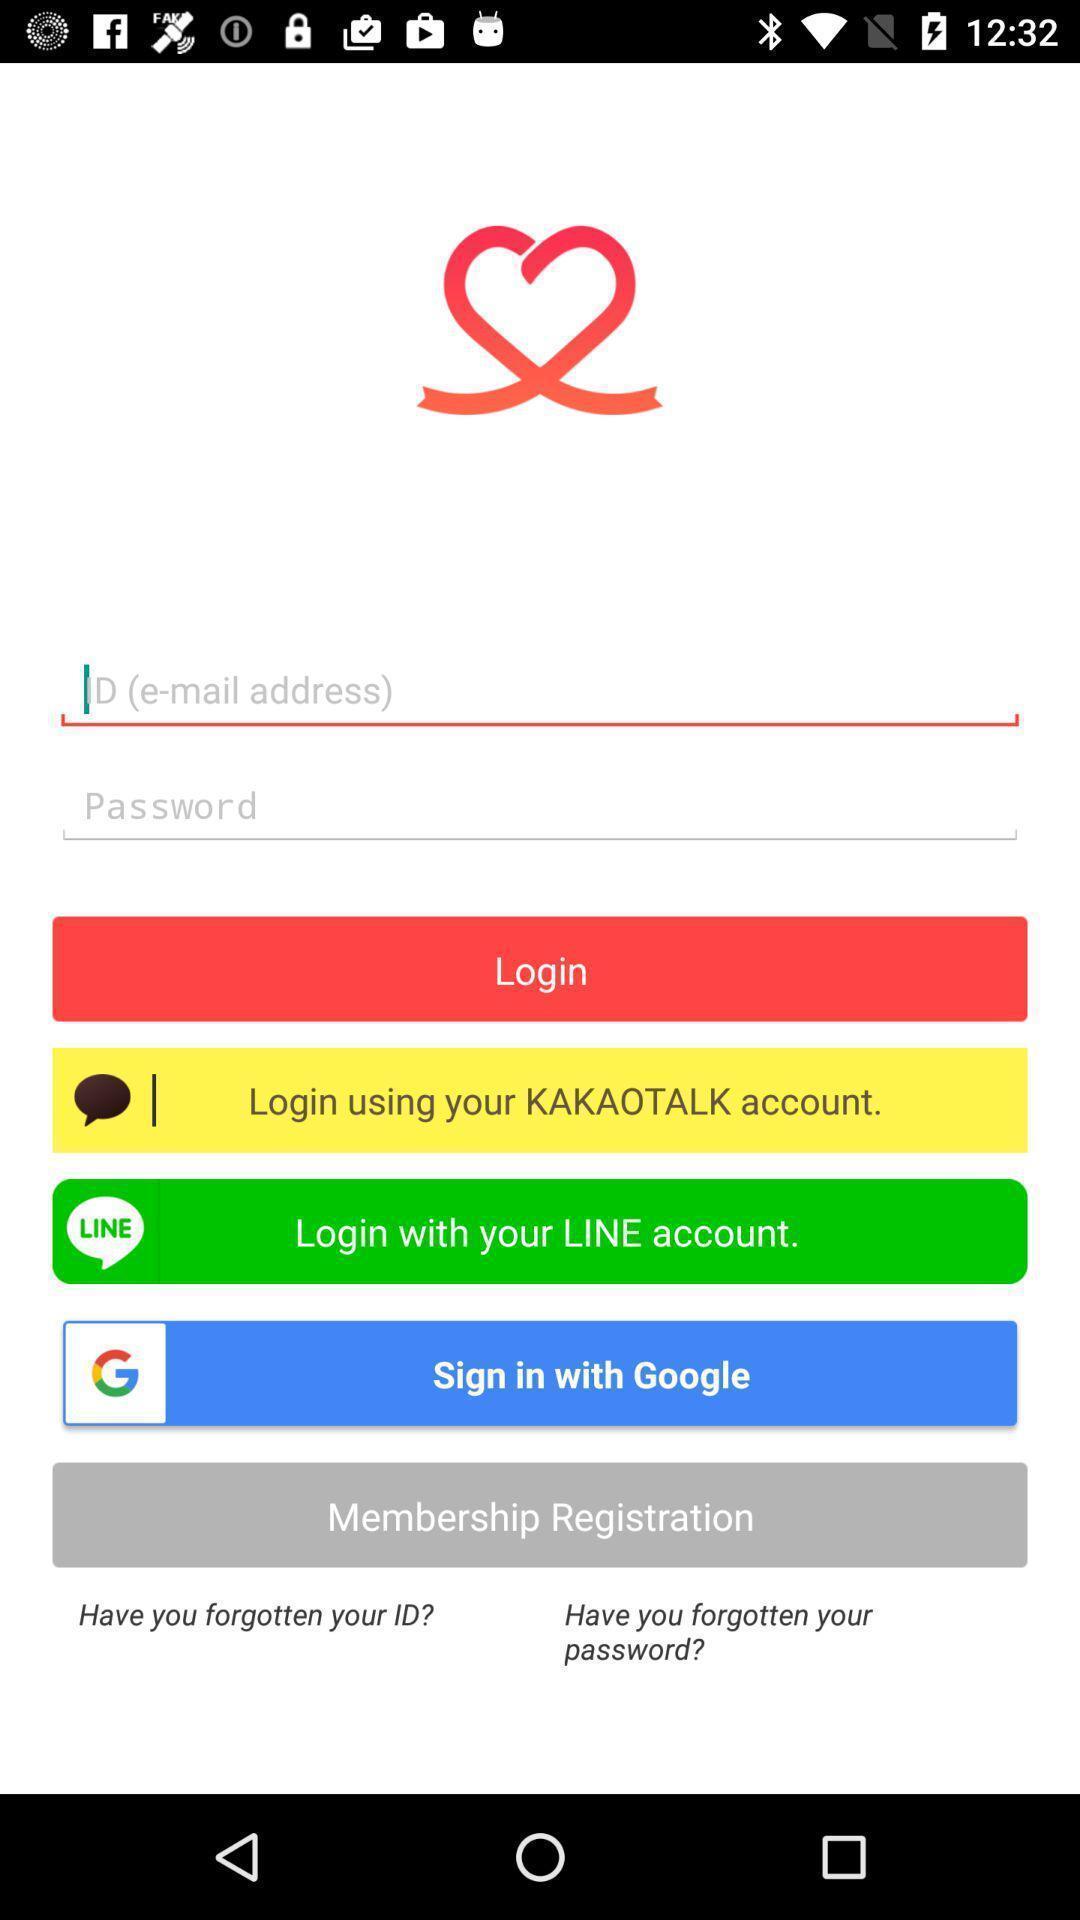Provide a detailed account of this screenshot. Page displaying the details to login through social app. 